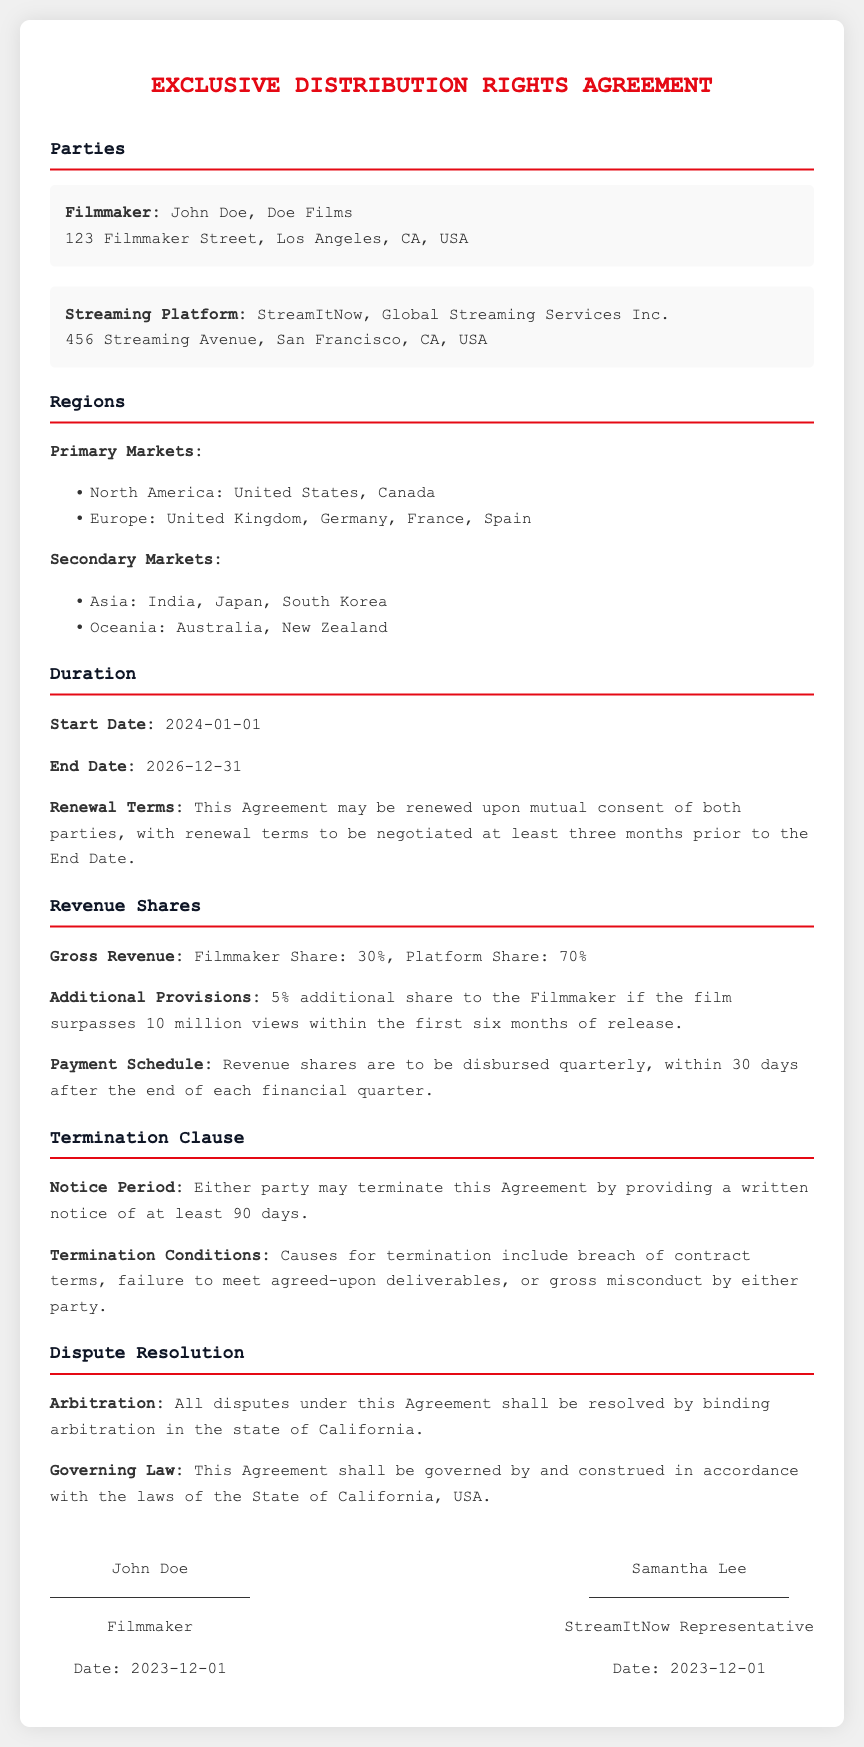What is the name of the Filmmaker? The Filmmaker is identified as John Doe in the document.
Answer: John Doe What is the geographical region for Secondary Markets? Secondary Markets include regions such as Asia and Oceania as specified in the document.
Answer: Asia, Oceania What is the start date of the Agreement? The Agreement explicitly states that it starts on January 1, 2024.
Answer: 2024-01-01 What percentage of Gross Revenue does the Filmmaker receive? The document details that the Filmmaker receives a 30% share of the Gross Revenue.
Answer: 30% What is the notice period for termination? The document specifies that a notice period of at least 90 days is required for termination.
Answer: 90 days What additional share does the Filmmaker receive for exceeding views? The document mentions that the Filmmaker receives a 5% additional share if the film surpasses 10 million views.
Answer: 5% Where will disputes be resolved according to the Agreement? The Arbitration section of the document indicates disputes will be resolved in California.
Answer: California What is the end date of the Agreement? The Agreement clearly states that it ends on December 31, 2026.
Answer: 2026-12-31 